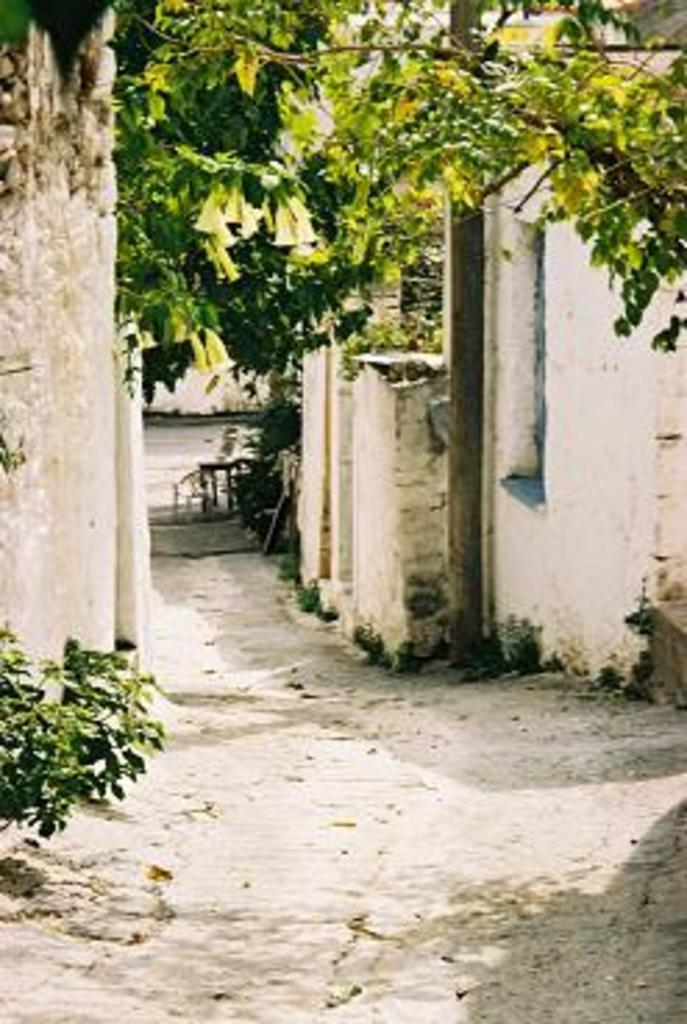What type of vegetation can be seen in the image? There are trees in the image. What is located in the center of the image? There is a pole in the center of the image. What type of structure is present in the image? There is a wall in the image. What color is the wall in the image? The wall is white in color. What type of smell can be detected from the trees in the image? There is no information about the smell of the trees in the image, as it is a visual medium. Is there a crib present in the image? No, there is no crib present in the image. 